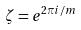Convert formula to latex. <formula><loc_0><loc_0><loc_500><loc_500>\zeta = e ^ { 2 \pi i / m }</formula> 